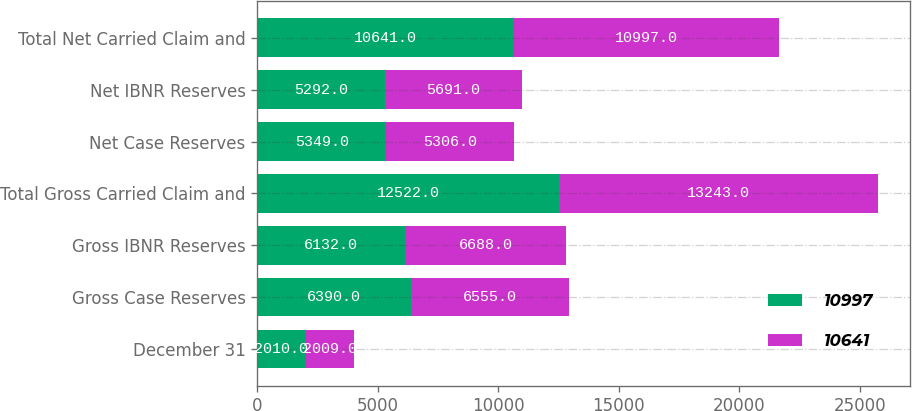Convert chart. <chart><loc_0><loc_0><loc_500><loc_500><stacked_bar_chart><ecel><fcel>December 31<fcel>Gross Case Reserves<fcel>Gross IBNR Reserves<fcel>Total Gross Carried Claim and<fcel>Net Case Reserves<fcel>Net IBNR Reserves<fcel>Total Net Carried Claim and<nl><fcel>10997<fcel>2010<fcel>6390<fcel>6132<fcel>12522<fcel>5349<fcel>5292<fcel>10641<nl><fcel>10641<fcel>2009<fcel>6555<fcel>6688<fcel>13243<fcel>5306<fcel>5691<fcel>10997<nl></chart> 